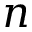Convert formula to latex. <formula><loc_0><loc_0><loc_500><loc_500>n</formula> 